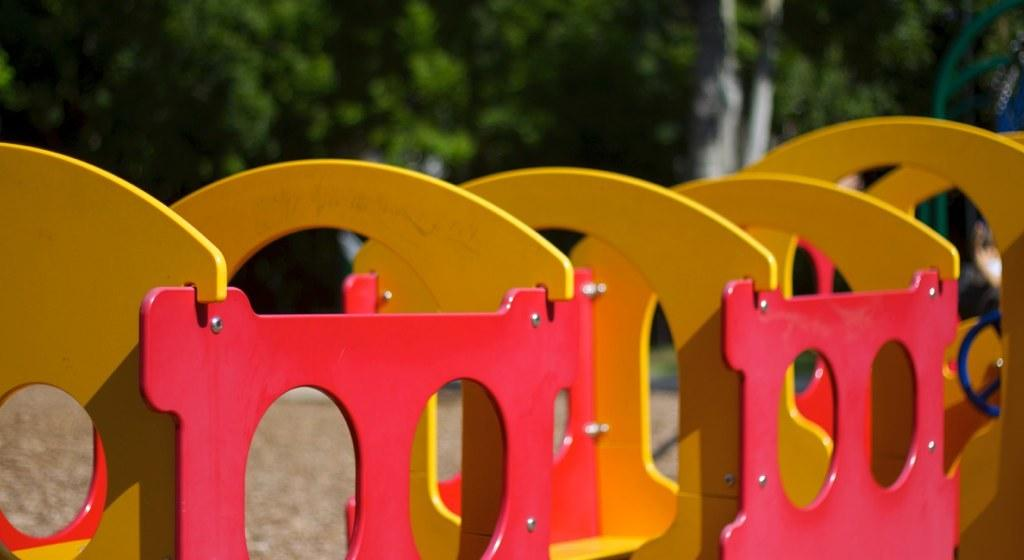What is the main subject of the image? There is a fun ride in the image. What can be seen in the background of the image? There are trees in the background of the image. Where is the crook hiding in the image? There is no crook present in the image. What type of truck can be seen in the image? There is no truck present in the image. 